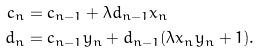<formula> <loc_0><loc_0><loc_500><loc_500>c _ { n } & = c _ { n - 1 } + \lambda d _ { n - 1 } x _ { n } \\ d _ { n } & = c _ { n - 1 } y _ { n } + d _ { n - 1 } ( \lambda x _ { n } y _ { n } + 1 ) .</formula> 